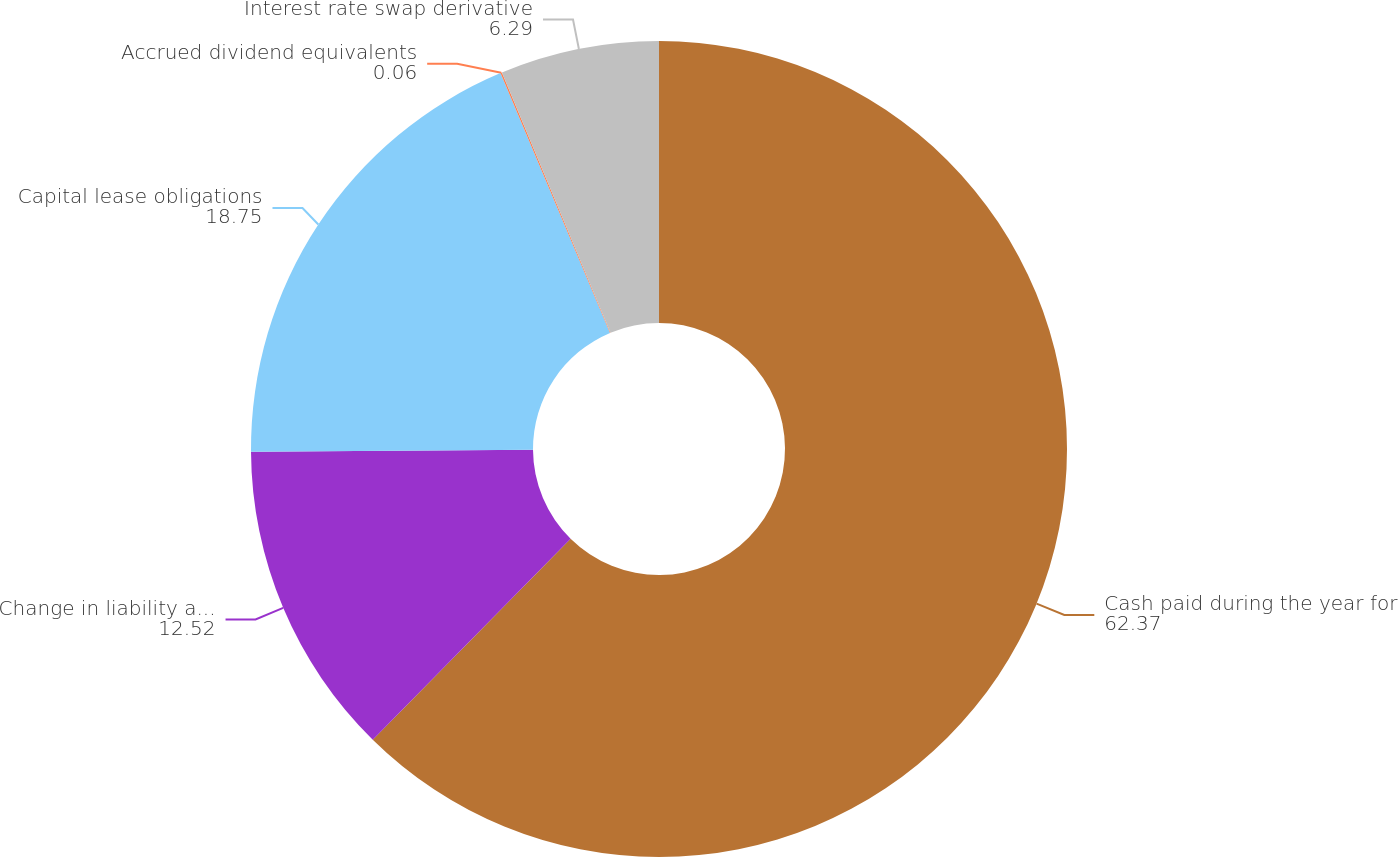Convert chart. <chart><loc_0><loc_0><loc_500><loc_500><pie_chart><fcel>Cash paid during the year for<fcel>Change in liability associated<fcel>Capital lease obligations<fcel>Accrued dividend equivalents<fcel>Interest rate swap derivative<nl><fcel>62.37%<fcel>12.52%<fcel>18.75%<fcel>0.06%<fcel>6.29%<nl></chart> 